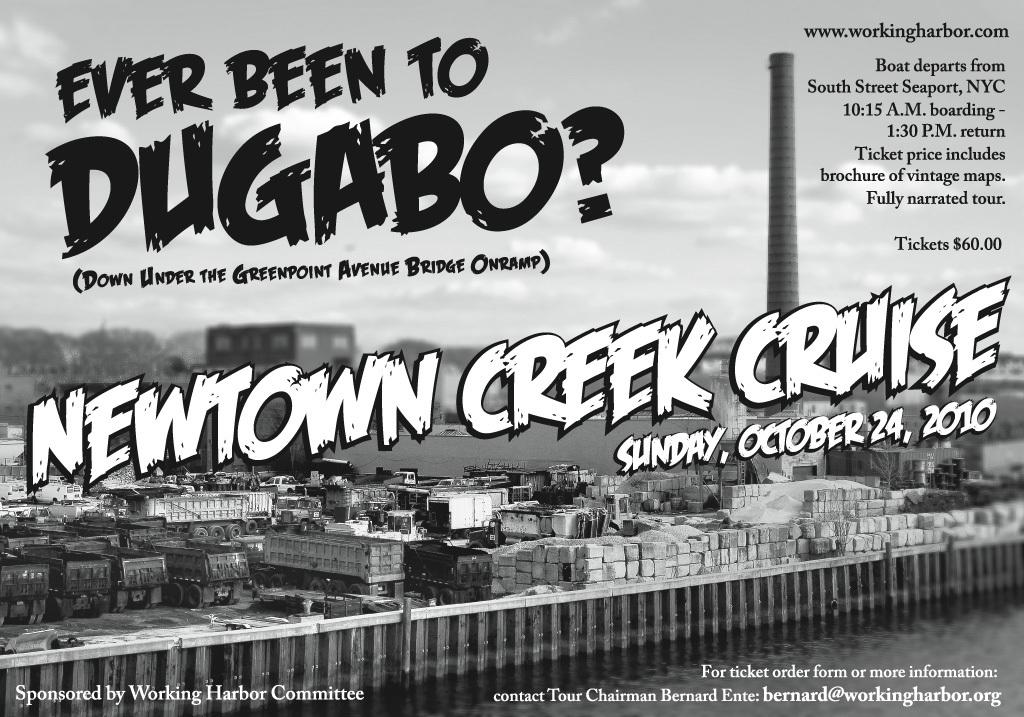<image>
Share a concise interpretation of the image provided. an advertisement from newtown creek cruise asking if the reader has been to dugabo. 